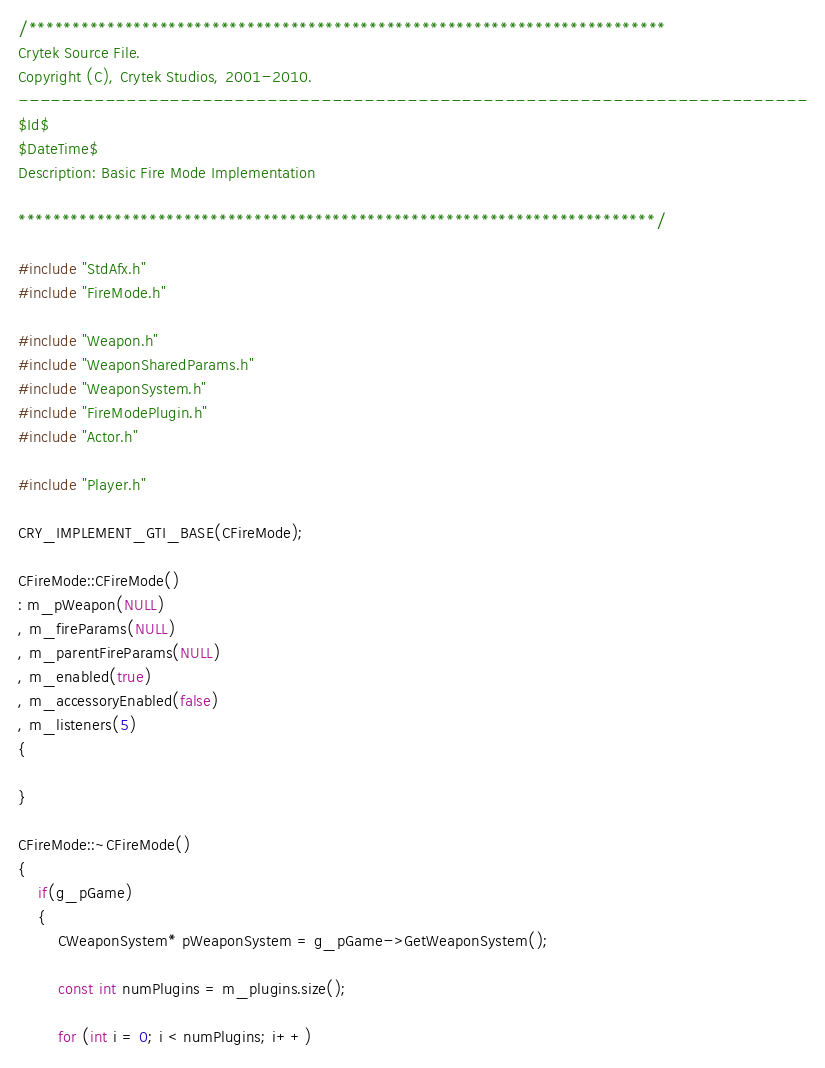Convert code to text. <code><loc_0><loc_0><loc_500><loc_500><_C++_>/*************************************************************************
Crytek Source File.
Copyright (C), Crytek Studios, 2001-2010.
-------------------------------------------------------------------------
$Id$
$DateTime$
Description: Basic Fire Mode Implementation

*************************************************************************/

#include "StdAfx.h"
#include "FireMode.h"

#include "Weapon.h"
#include "WeaponSharedParams.h"
#include "WeaponSystem.h"
#include "FireModePlugin.h"
#include "Actor.h"

#include "Player.h"

CRY_IMPLEMENT_GTI_BASE(CFireMode);

CFireMode::CFireMode() 
: m_pWeapon(NULL)
, m_fireParams(NULL)
, m_parentFireParams(NULL)
, m_enabled(true)
, m_accessoryEnabled(false)
, m_listeners(5)
{

}

CFireMode::~CFireMode()
{
	if(g_pGame)
	{
		CWeaponSystem* pWeaponSystem = g_pGame->GetWeaponSystem();

		const int numPlugins = m_plugins.size();

		for (int i = 0; i < numPlugins; i++)</code> 